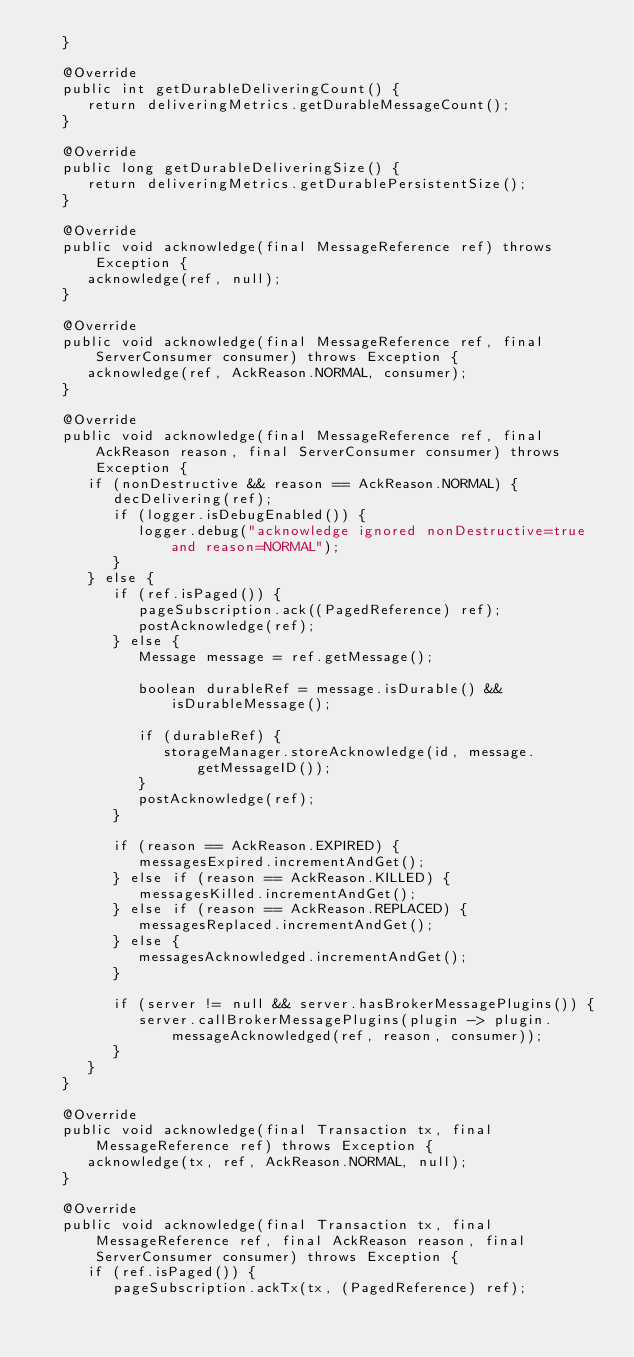<code> <loc_0><loc_0><loc_500><loc_500><_Java_>   }

   @Override
   public int getDurableDeliveringCount() {
      return deliveringMetrics.getDurableMessageCount();
   }

   @Override
   public long getDurableDeliveringSize() {
      return deliveringMetrics.getDurablePersistentSize();
   }

   @Override
   public void acknowledge(final MessageReference ref) throws Exception {
      acknowledge(ref, null);
   }

   @Override
   public void acknowledge(final MessageReference ref, final ServerConsumer consumer) throws Exception {
      acknowledge(ref, AckReason.NORMAL, consumer);
   }

   @Override
   public void acknowledge(final MessageReference ref, final AckReason reason, final ServerConsumer consumer) throws Exception {
      if (nonDestructive && reason == AckReason.NORMAL) {
         decDelivering(ref);
         if (logger.isDebugEnabled()) {
            logger.debug("acknowledge ignored nonDestructive=true and reason=NORMAL");
         }
      } else {
         if (ref.isPaged()) {
            pageSubscription.ack((PagedReference) ref);
            postAcknowledge(ref);
         } else {
            Message message = ref.getMessage();

            boolean durableRef = message.isDurable() && isDurableMessage();

            if (durableRef) {
               storageManager.storeAcknowledge(id, message.getMessageID());
            }
            postAcknowledge(ref);
         }

         if (reason == AckReason.EXPIRED) {
            messagesExpired.incrementAndGet();
         } else if (reason == AckReason.KILLED) {
            messagesKilled.incrementAndGet();
         } else if (reason == AckReason.REPLACED) {
            messagesReplaced.incrementAndGet();
         } else {
            messagesAcknowledged.incrementAndGet();
         }

         if (server != null && server.hasBrokerMessagePlugins()) {
            server.callBrokerMessagePlugins(plugin -> plugin.messageAcknowledged(ref, reason, consumer));
         }
      }
   }

   @Override
   public void acknowledge(final Transaction tx, final MessageReference ref) throws Exception {
      acknowledge(tx, ref, AckReason.NORMAL, null);
   }

   @Override
   public void acknowledge(final Transaction tx, final MessageReference ref, final AckReason reason, final ServerConsumer consumer) throws Exception {
      if (ref.isPaged()) {
         pageSubscription.ackTx(tx, (PagedReference) ref);
</code> 